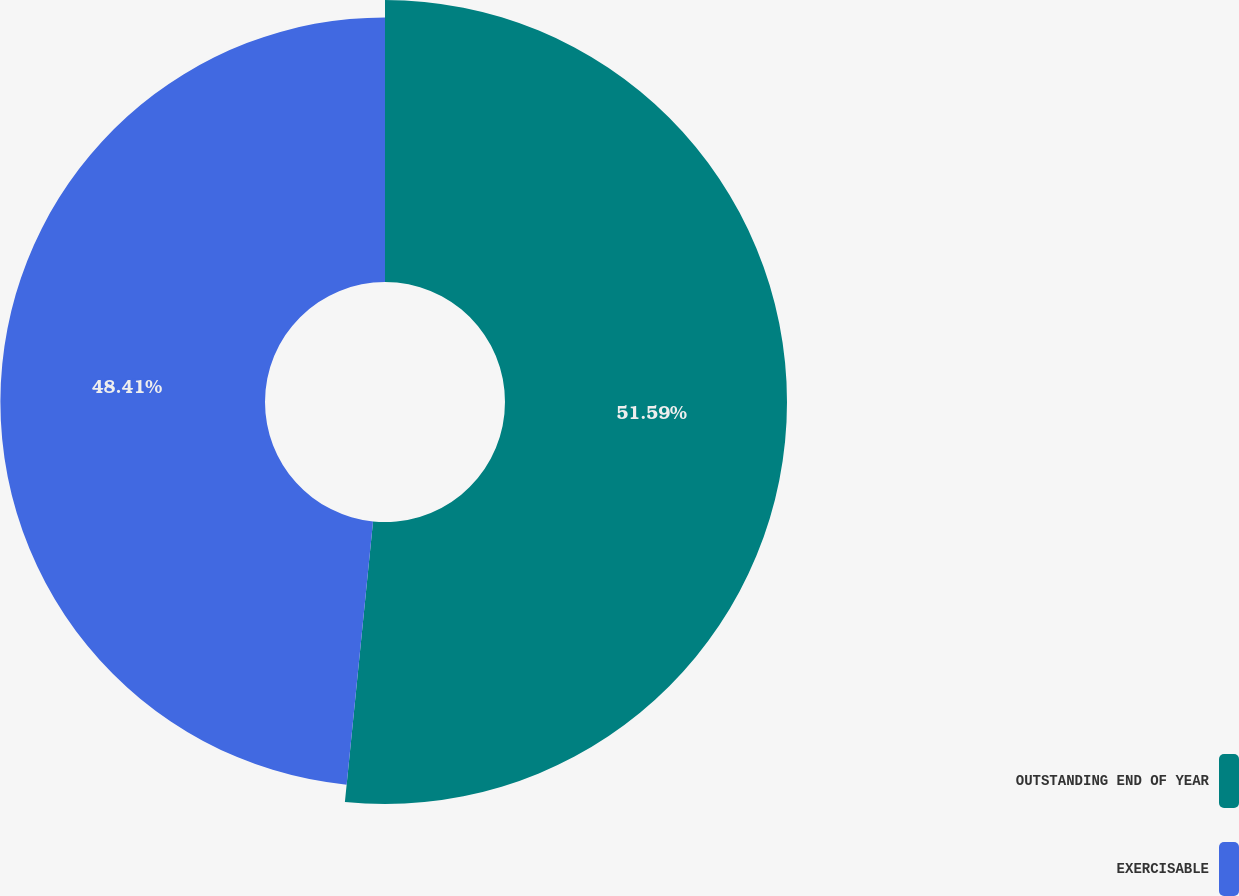Convert chart to OTSL. <chart><loc_0><loc_0><loc_500><loc_500><pie_chart><fcel>OUTSTANDING END OF YEAR<fcel>EXERCISABLE<nl><fcel>51.59%<fcel>48.41%<nl></chart> 